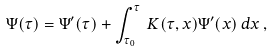Convert formula to latex. <formula><loc_0><loc_0><loc_500><loc_500>\Psi ( \tau ) = \Psi ^ { \prime } ( \tau ) + \int _ { \tau _ { 0 } } ^ { \tau } \, K ( \tau , x ) \Psi ^ { \prime } ( x ) \, d x \, ,</formula> 